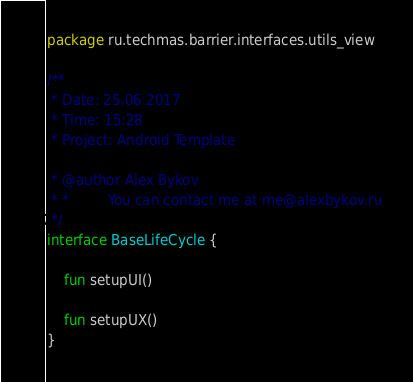Convert code to text. <code><loc_0><loc_0><loc_500><loc_500><_Kotlin_>package ru.techmas.barrier.interfaces.utils_view

/**
 * Date: 25.06.2017
 * Time: 15:28
 * Project: Android Template

 * @author Alex Bykov
 * *         You can contact me at me@alexbykov.ru
 */
interface BaseLifeCycle {

    fun setupUI()

    fun setupUX()
}
</code> 